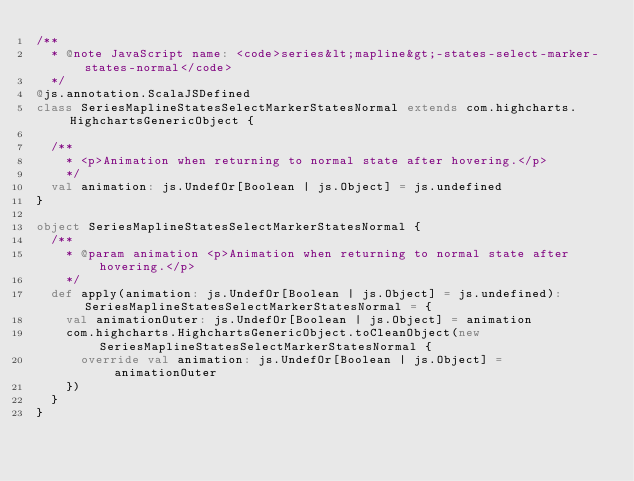Convert code to text. <code><loc_0><loc_0><loc_500><loc_500><_Scala_>/**
  * @note JavaScript name: <code>series&lt;mapline&gt;-states-select-marker-states-normal</code>
  */
@js.annotation.ScalaJSDefined
class SeriesMaplineStatesSelectMarkerStatesNormal extends com.highcharts.HighchartsGenericObject {

  /**
    * <p>Animation when returning to normal state after hovering.</p>
    */
  val animation: js.UndefOr[Boolean | js.Object] = js.undefined
}

object SeriesMaplineStatesSelectMarkerStatesNormal {
  /**
    * @param animation <p>Animation when returning to normal state after hovering.</p>
    */
  def apply(animation: js.UndefOr[Boolean | js.Object] = js.undefined): SeriesMaplineStatesSelectMarkerStatesNormal = {
    val animationOuter: js.UndefOr[Boolean | js.Object] = animation
    com.highcharts.HighchartsGenericObject.toCleanObject(new SeriesMaplineStatesSelectMarkerStatesNormal {
      override val animation: js.UndefOr[Boolean | js.Object] = animationOuter
    })
  }
}
</code> 